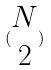<formula> <loc_0><loc_0><loc_500><loc_500>( \begin{matrix} N \\ 2 \end{matrix} )</formula> 